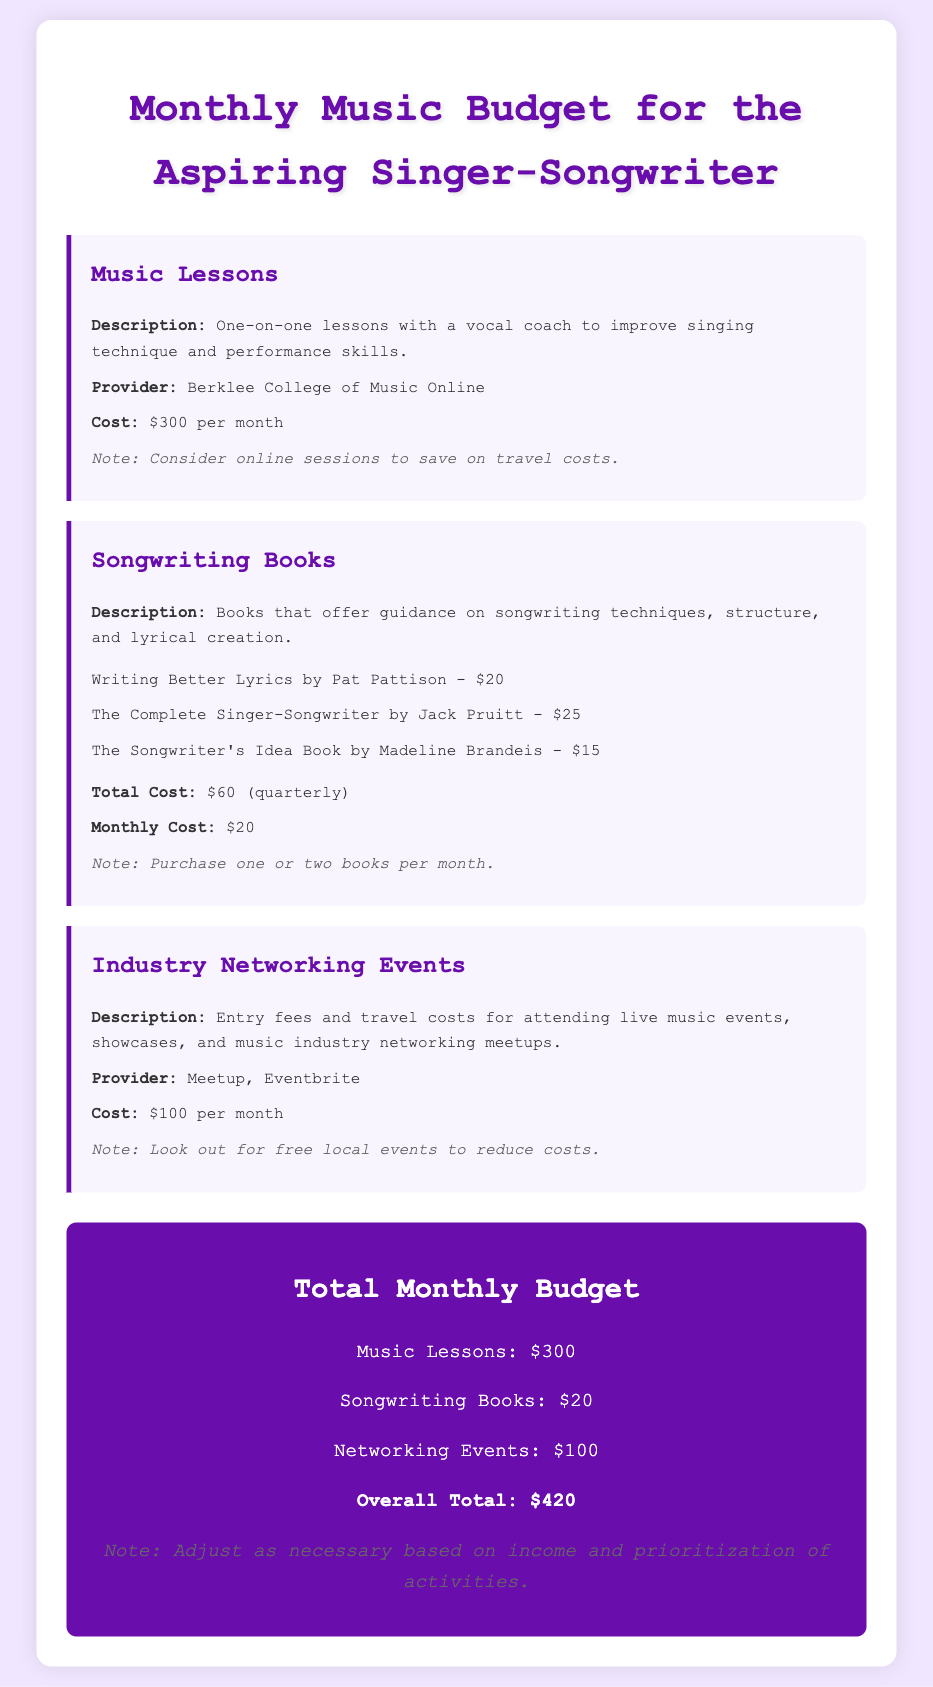What is the cost of music lessons? The document states that music lessons cost $300 per month.
Answer: $300 How much is spent on songwriting books per month? The monthly cost for songwriting books is specified as $20.
Answer: $20 What is the total monthly budget for all activities? The overall total mentioned in the document sums up all expenses to be $420.
Answer: $420 Which provider offers the music lessons? The music lessons are provided by Berklee College of Music Online.
Answer: Berklee College of Music Online How many songwriting books are listed in the document? Three songwriting books are mentioned in the budget breakdown.
Answer: Three What is the monthly cost for attending industry networking events? The document indicates that entry fees and travel costs for networking events amount to $100 per month.
Answer: $100 What is one suggestion to save on travel costs for music lessons? The document suggests considering online sessions to save on travel costs.
Answer: Online sessions What is the total cost for songwriting books listed quarterly? The document states the total cost for songwriting books, mentioned quarterly, is $60.
Answer: $60 What is a note regarding attending industry networking events? The document notes to look out for free local events to reduce costs when attending networking events.
Answer: Free local events 